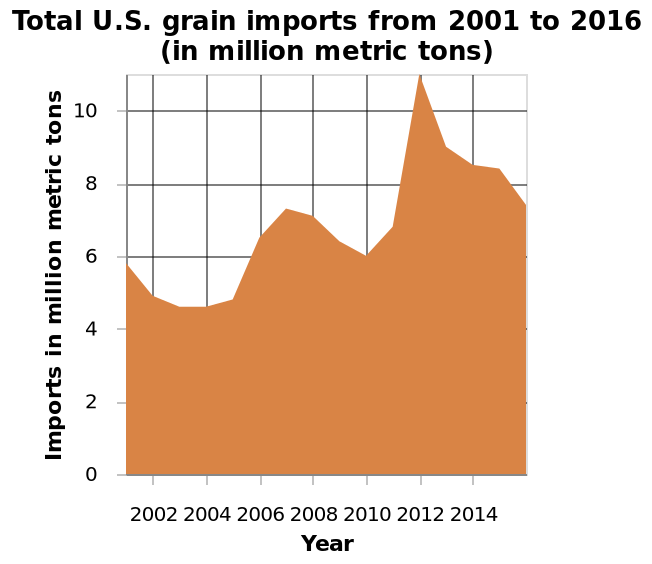<image>
What does the x-axis represent in the area chart?  The x-axis represents the years from 2001 to 2016. Did the grain import in the US increase or decrease from the previous year of the highest import in 2012? The grain import in the US increased significantly from the previous year when it reached its highest import in 2012. What is the unit of measurement for the grain imports on the y-axis? The unit of measurement for the grain imports on the y-axis is million metric tons. 